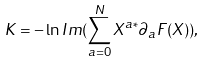Convert formula to latex. <formula><loc_0><loc_0><loc_500><loc_500>K = - \ln I m ( \sum _ { a = 0 } ^ { N } X ^ { a * } \partial _ { a } F ( X ) ) ,</formula> 